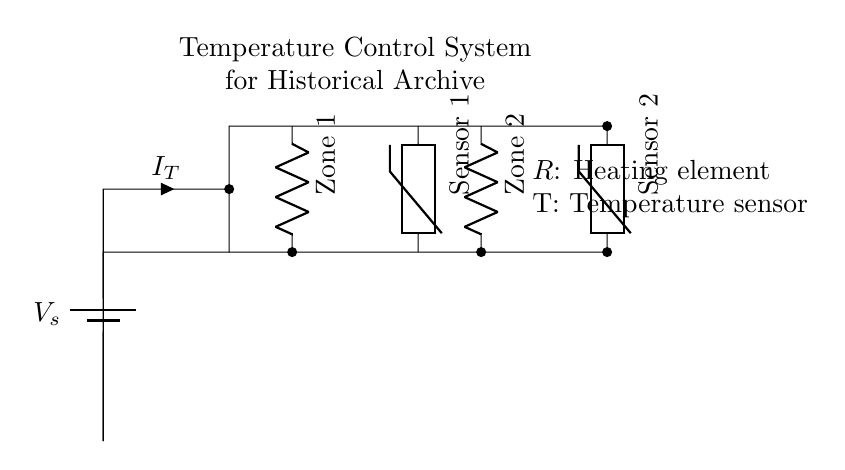What is the type of circuit shown? The circuit is a parallel circuit because multiple components are connected across the same two points, allowing each one to operate independently.
Answer: Parallel How many temperature zones are controlled by this circuit? The circuit has two distinct zones labeled as Zone 1 and Zone 2, each equipped with its own heating element.
Answer: Two What type of sensors are used in the circuit? The sensors depicted are thermistors, which are components sensitive to temperature changes, allowing for temperature monitoring in each zone.
Answer: Thermistors What is the main purpose of this circuit? The primary purpose of this circuit is to maintain and control temperature for preserving historical archive materials across multiple zones.
Answer: Temperature control What is the current flowing through the circuit represented as? In the circuit, the total current is represented as \( I_T \), which is indicated to flow from the source through each of the components in parallel.
Answer: I_T Which component provides the heating element for Zone 1? The heating element for Zone 1 is represented by a resistor denoted as Zone 1 in the circuit diagram, which is responsible for heating that specific area.
Answer: Resistor What is the function of the battery in this circuit? The battery, labeled \( V_s \), acts as the power source providing the necessary voltage for current to flow through the circuit and operate the heating elements and sensors.
Answer: Power source 